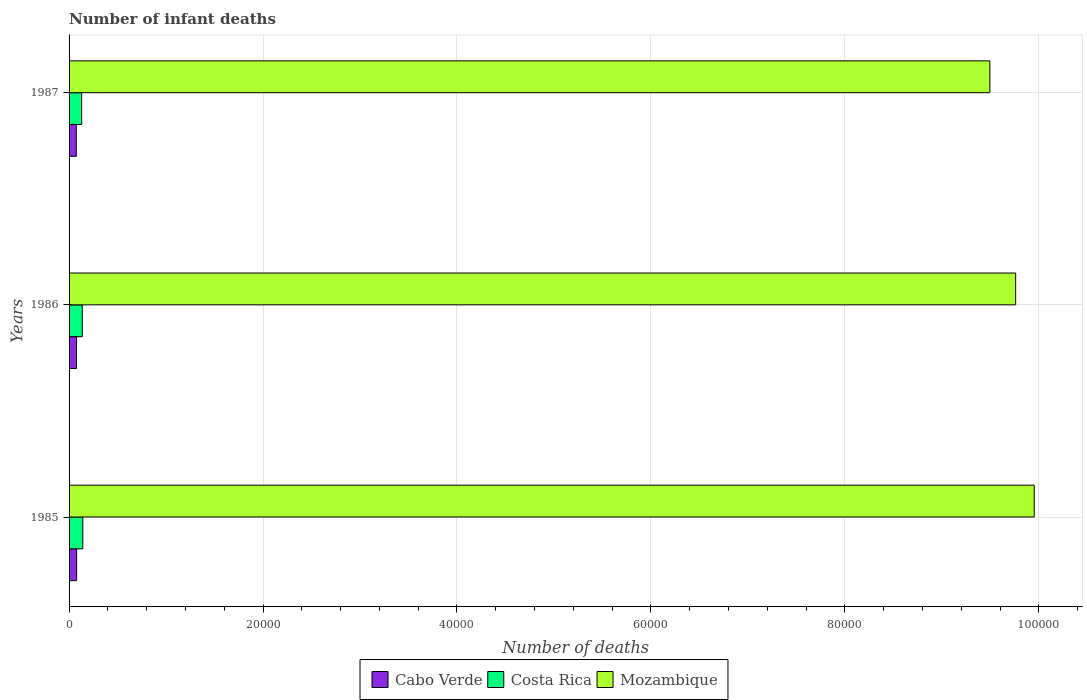How many groups of bars are there?
Ensure brevity in your answer.  3. Are the number of bars per tick equal to the number of legend labels?
Keep it short and to the point. Yes. What is the label of the 1st group of bars from the top?
Give a very brief answer. 1987. What is the number of infant deaths in Mozambique in 1985?
Provide a succinct answer. 9.95e+04. Across all years, what is the maximum number of infant deaths in Costa Rica?
Ensure brevity in your answer.  1417. Across all years, what is the minimum number of infant deaths in Costa Rica?
Your answer should be compact. 1297. What is the total number of infant deaths in Cabo Verde in the graph?
Make the answer very short. 2291. What is the difference between the number of infant deaths in Costa Rica in 1985 and that in 1987?
Your answer should be compact. 120. What is the difference between the number of infant deaths in Mozambique in 1985 and the number of infant deaths in Cabo Verde in 1986?
Provide a short and direct response. 9.88e+04. What is the average number of infant deaths in Cabo Verde per year?
Your answer should be compact. 763.67. In the year 1985, what is the difference between the number of infant deaths in Costa Rica and number of infant deaths in Cabo Verde?
Your response must be concise. 638. What is the ratio of the number of infant deaths in Cabo Verde in 1985 to that in 1987?
Your response must be concise. 1.05. What is the difference between the highest and the second highest number of infant deaths in Mozambique?
Offer a very short reply. 1916. What is the difference between the highest and the lowest number of infant deaths in Cabo Verde?
Keep it short and to the point. 34. In how many years, is the number of infant deaths in Cabo Verde greater than the average number of infant deaths in Cabo Verde taken over all years?
Your answer should be compact. 2. What does the 1st bar from the top in 1985 represents?
Make the answer very short. Mozambique. What does the 3rd bar from the bottom in 1987 represents?
Your answer should be very brief. Mozambique. Is it the case that in every year, the sum of the number of infant deaths in Cabo Verde and number of infant deaths in Mozambique is greater than the number of infant deaths in Costa Rica?
Give a very brief answer. Yes. How many bars are there?
Your answer should be very brief. 9. Are all the bars in the graph horizontal?
Provide a short and direct response. Yes. What is the difference between two consecutive major ticks on the X-axis?
Provide a succinct answer. 2.00e+04. Does the graph contain grids?
Keep it short and to the point. Yes. How many legend labels are there?
Provide a succinct answer. 3. What is the title of the graph?
Make the answer very short. Number of infant deaths. Does "Togo" appear as one of the legend labels in the graph?
Provide a short and direct response. No. What is the label or title of the X-axis?
Your answer should be compact. Number of deaths. What is the Number of deaths of Cabo Verde in 1985?
Your answer should be very brief. 779. What is the Number of deaths of Costa Rica in 1985?
Keep it short and to the point. 1417. What is the Number of deaths in Mozambique in 1985?
Your answer should be compact. 9.95e+04. What is the Number of deaths of Cabo Verde in 1986?
Your answer should be very brief. 767. What is the Number of deaths of Costa Rica in 1986?
Offer a very short reply. 1360. What is the Number of deaths of Mozambique in 1986?
Your answer should be compact. 9.76e+04. What is the Number of deaths in Cabo Verde in 1987?
Offer a very short reply. 745. What is the Number of deaths in Costa Rica in 1987?
Offer a very short reply. 1297. What is the Number of deaths in Mozambique in 1987?
Make the answer very short. 9.49e+04. Across all years, what is the maximum Number of deaths of Cabo Verde?
Give a very brief answer. 779. Across all years, what is the maximum Number of deaths of Costa Rica?
Your answer should be very brief. 1417. Across all years, what is the maximum Number of deaths in Mozambique?
Your response must be concise. 9.95e+04. Across all years, what is the minimum Number of deaths of Cabo Verde?
Make the answer very short. 745. Across all years, what is the minimum Number of deaths of Costa Rica?
Make the answer very short. 1297. Across all years, what is the minimum Number of deaths of Mozambique?
Make the answer very short. 9.49e+04. What is the total Number of deaths in Cabo Verde in the graph?
Your answer should be very brief. 2291. What is the total Number of deaths in Costa Rica in the graph?
Your response must be concise. 4074. What is the total Number of deaths in Mozambique in the graph?
Offer a very short reply. 2.92e+05. What is the difference between the Number of deaths of Cabo Verde in 1985 and that in 1986?
Ensure brevity in your answer.  12. What is the difference between the Number of deaths of Costa Rica in 1985 and that in 1986?
Make the answer very short. 57. What is the difference between the Number of deaths of Mozambique in 1985 and that in 1986?
Make the answer very short. 1916. What is the difference between the Number of deaths in Costa Rica in 1985 and that in 1987?
Offer a terse response. 120. What is the difference between the Number of deaths in Mozambique in 1985 and that in 1987?
Your answer should be compact. 4576. What is the difference between the Number of deaths in Mozambique in 1986 and that in 1987?
Make the answer very short. 2660. What is the difference between the Number of deaths in Cabo Verde in 1985 and the Number of deaths in Costa Rica in 1986?
Offer a terse response. -581. What is the difference between the Number of deaths of Cabo Verde in 1985 and the Number of deaths of Mozambique in 1986?
Ensure brevity in your answer.  -9.68e+04. What is the difference between the Number of deaths in Costa Rica in 1985 and the Number of deaths in Mozambique in 1986?
Give a very brief answer. -9.62e+04. What is the difference between the Number of deaths in Cabo Verde in 1985 and the Number of deaths in Costa Rica in 1987?
Keep it short and to the point. -518. What is the difference between the Number of deaths in Cabo Verde in 1985 and the Number of deaths in Mozambique in 1987?
Make the answer very short. -9.42e+04. What is the difference between the Number of deaths in Costa Rica in 1985 and the Number of deaths in Mozambique in 1987?
Your response must be concise. -9.35e+04. What is the difference between the Number of deaths in Cabo Verde in 1986 and the Number of deaths in Costa Rica in 1987?
Your answer should be compact. -530. What is the difference between the Number of deaths in Cabo Verde in 1986 and the Number of deaths in Mozambique in 1987?
Offer a terse response. -9.42e+04. What is the difference between the Number of deaths of Costa Rica in 1986 and the Number of deaths of Mozambique in 1987?
Provide a short and direct response. -9.36e+04. What is the average Number of deaths in Cabo Verde per year?
Offer a terse response. 763.67. What is the average Number of deaths of Costa Rica per year?
Offer a very short reply. 1358. What is the average Number of deaths of Mozambique per year?
Provide a short and direct response. 9.74e+04. In the year 1985, what is the difference between the Number of deaths in Cabo Verde and Number of deaths in Costa Rica?
Provide a succinct answer. -638. In the year 1985, what is the difference between the Number of deaths in Cabo Verde and Number of deaths in Mozambique?
Offer a very short reply. -9.87e+04. In the year 1985, what is the difference between the Number of deaths in Costa Rica and Number of deaths in Mozambique?
Keep it short and to the point. -9.81e+04. In the year 1986, what is the difference between the Number of deaths of Cabo Verde and Number of deaths of Costa Rica?
Provide a short and direct response. -593. In the year 1986, what is the difference between the Number of deaths of Cabo Verde and Number of deaths of Mozambique?
Give a very brief answer. -9.68e+04. In the year 1986, what is the difference between the Number of deaths of Costa Rica and Number of deaths of Mozambique?
Make the answer very short. -9.62e+04. In the year 1987, what is the difference between the Number of deaths of Cabo Verde and Number of deaths of Costa Rica?
Your answer should be compact. -552. In the year 1987, what is the difference between the Number of deaths in Cabo Verde and Number of deaths in Mozambique?
Give a very brief answer. -9.42e+04. In the year 1987, what is the difference between the Number of deaths in Costa Rica and Number of deaths in Mozambique?
Provide a succinct answer. -9.36e+04. What is the ratio of the Number of deaths of Cabo Verde in 1985 to that in 1986?
Provide a short and direct response. 1.02. What is the ratio of the Number of deaths in Costa Rica in 1985 to that in 1986?
Offer a terse response. 1.04. What is the ratio of the Number of deaths in Mozambique in 1985 to that in 1986?
Your response must be concise. 1.02. What is the ratio of the Number of deaths of Cabo Verde in 1985 to that in 1987?
Your answer should be compact. 1.05. What is the ratio of the Number of deaths of Costa Rica in 1985 to that in 1987?
Your answer should be very brief. 1.09. What is the ratio of the Number of deaths in Mozambique in 1985 to that in 1987?
Your answer should be very brief. 1.05. What is the ratio of the Number of deaths of Cabo Verde in 1986 to that in 1987?
Give a very brief answer. 1.03. What is the ratio of the Number of deaths in Costa Rica in 1986 to that in 1987?
Ensure brevity in your answer.  1.05. What is the ratio of the Number of deaths in Mozambique in 1986 to that in 1987?
Your response must be concise. 1.03. What is the difference between the highest and the second highest Number of deaths in Cabo Verde?
Your answer should be compact. 12. What is the difference between the highest and the second highest Number of deaths in Mozambique?
Offer a very short reply. 1916. What is the difference between the highest and the lowest Number of deaths in Cabo Verde?
Keep it short and to the point. 34. What is the difference between the highest and the lowest Number of deaths in Costa Rica?
Keep it short and to the point. 120. What is the difference between the highest and the lowest Number of deaths in Mozambique?
Provide a short and direct response. 4576. 